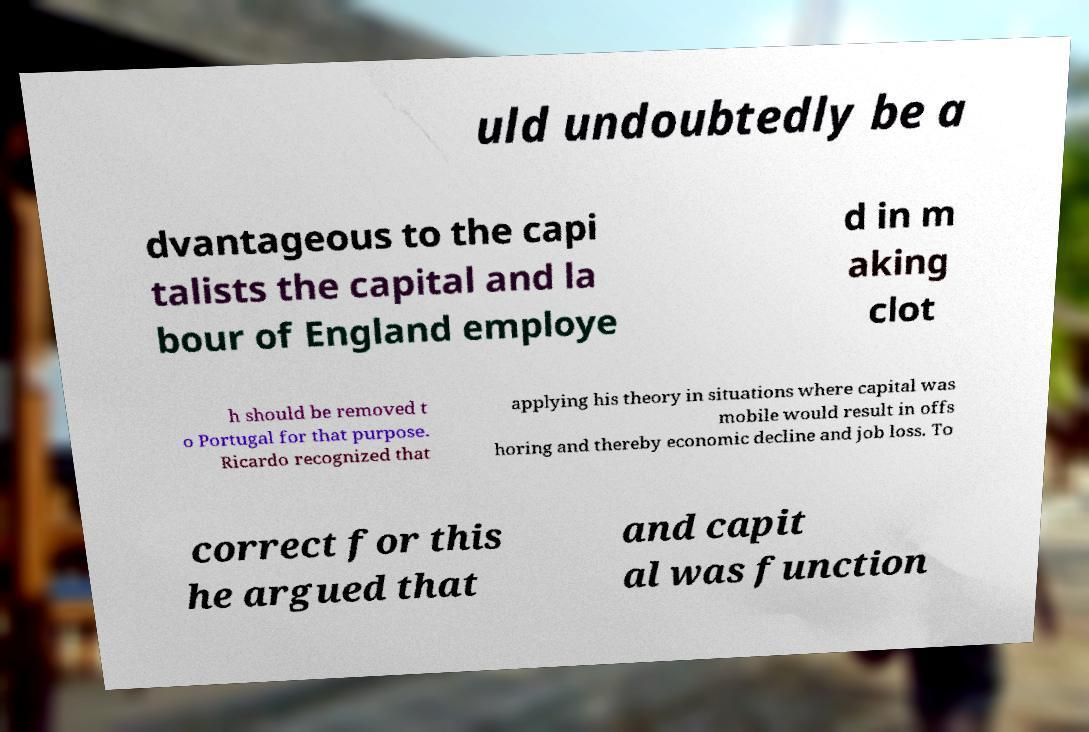For documentation purposes, I need the text within this image transcribed. Could you provide that? uld undoubtedly be a dvantageous to the capi talists the capital and la bour of England employe d in m aking clot h should be removed t o Portugal for that purpose. Ricardo recognized that applying his theory in situations where capital was mobile would result in offs horing and thereby economic decline and job loss. To correct for this he argued that and capit al was function 